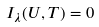Convert formula to latex. <formula><loc_0><loc_0><loc_500><loc_500>I _ { \lambda } ( U , T ) = 0</formula> 